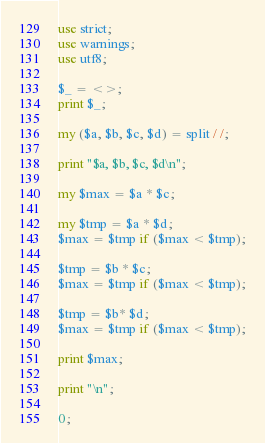<code> <loc_0><loc_0><loc_500><loc_500><_Perl_>use strict;
use warnings;
use utf8;

$_ = <>;
print $_;

my ($a, $b, $c, $d) = split / /;

print "$a, $b, $c, $d\n";

my $max = $a * $c;

my $tmp = $a * $d;
$max = $tmp if ($max < $tmp);

$tmp = $b * $c;
$max = $tmp if ($max < $tmp);

$tmp = $b* $d;
$max = $tmp if ($max < $tmp);

print $max;

print "\n";

0;
</code> 